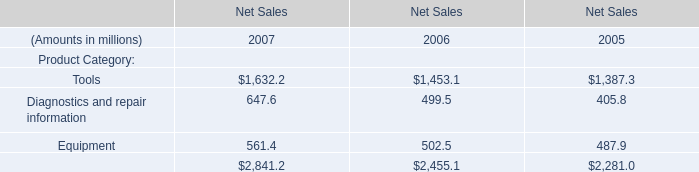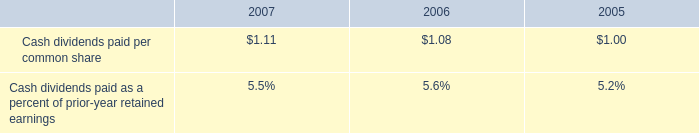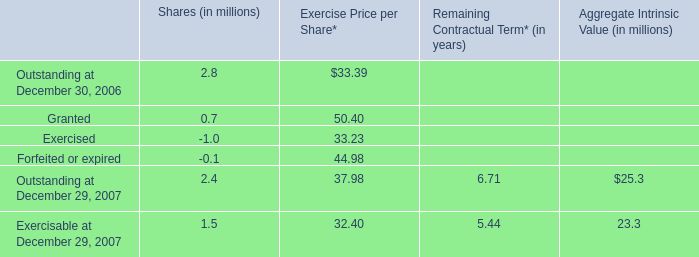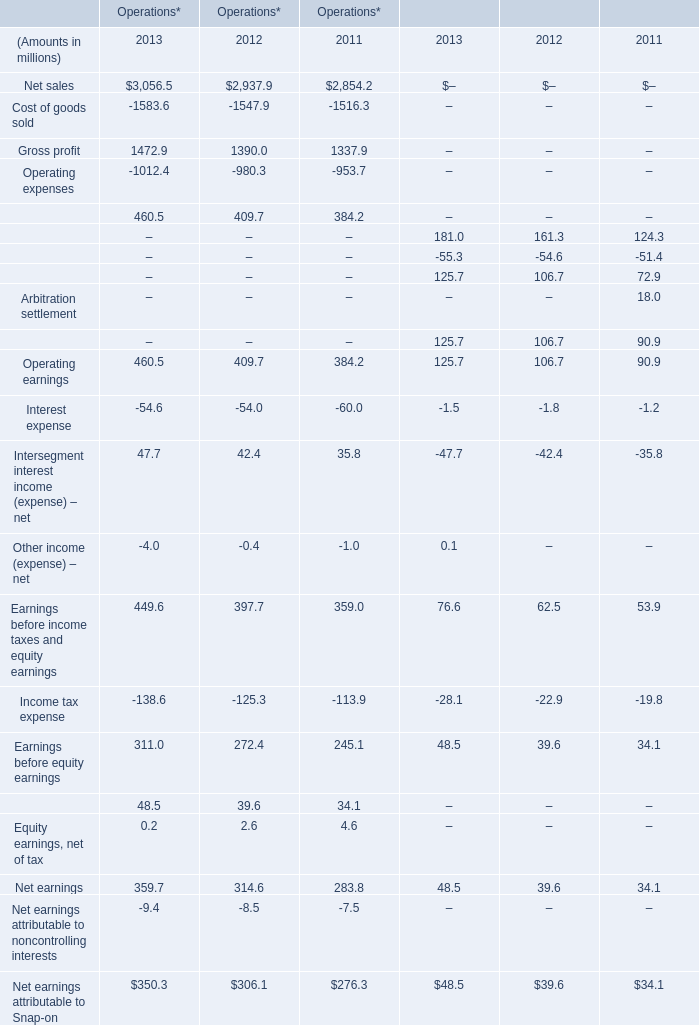What's the current growth rate of Financial services revenue for financial services? (in %) 
Computations: ((181 - 161.3) / 161.3)
Answer: 0.12213. 